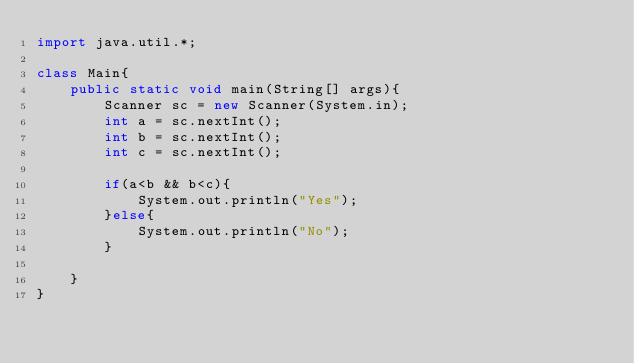Convert code to text. <code><loc_0><loc_0><loc_500><loc_500><_Java_>import java.util.*;

class Main{
	public static void main(String[] args){
		Scanner sc = new Scanner(System.in);
		int a = sc.nextInt();
		int b = sc.nextInt();
        int c = sc.nextInt();

		if(a<b && b<c){
			System.out.println("Yes");
		}else{
            System.out.println("No");
        }

	}
}
</code> 